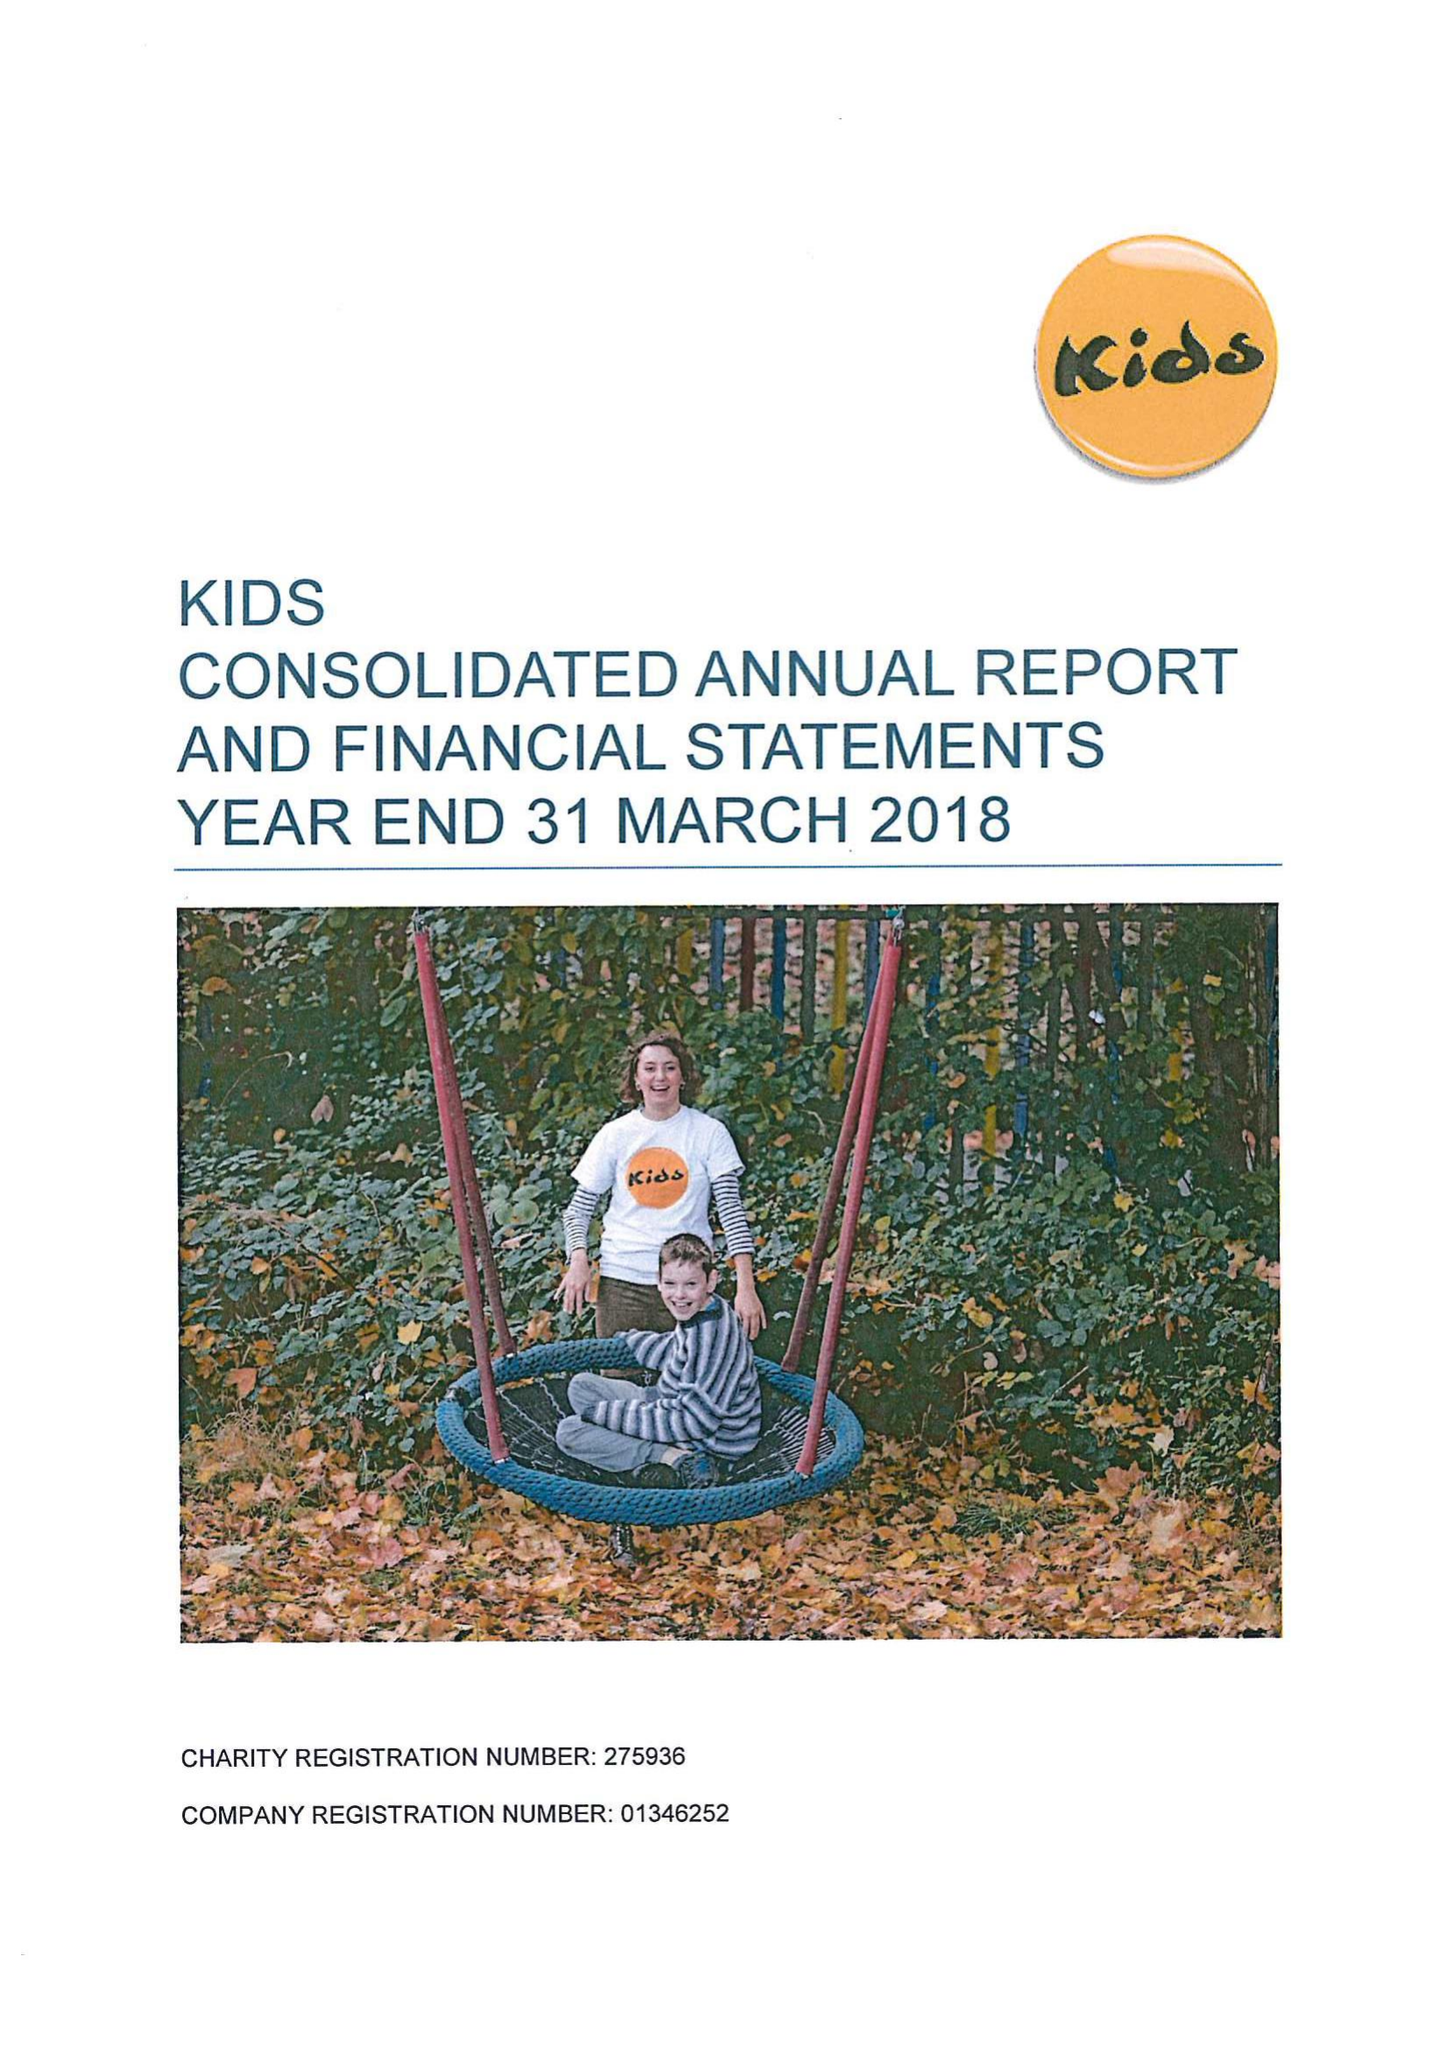What is the value for the charity_name?
Answer the question using a single word or phrase. Kids 